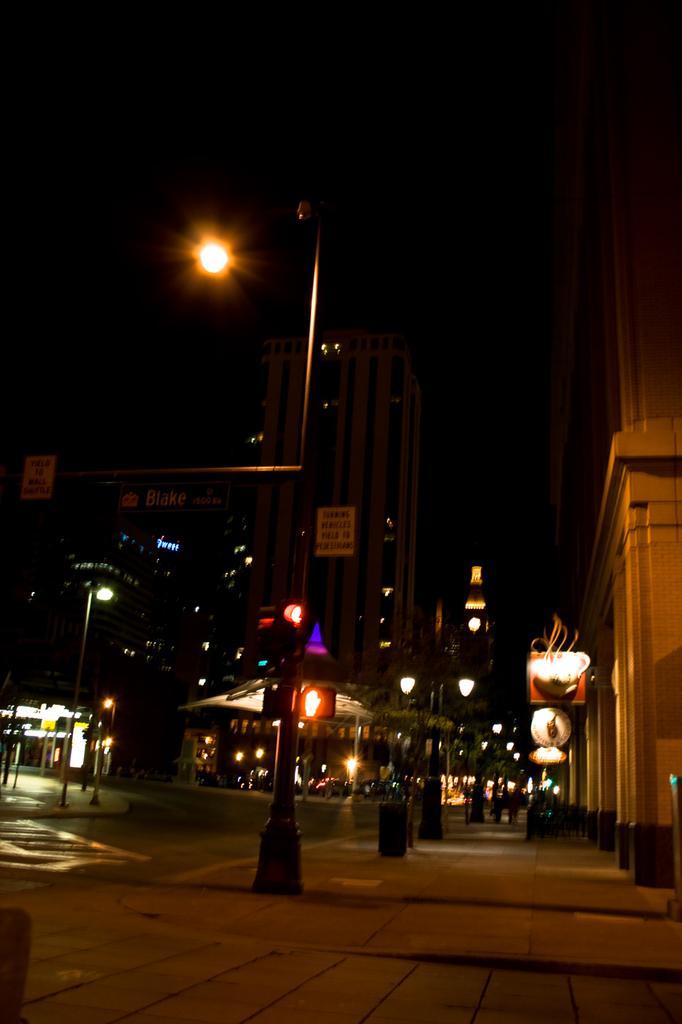Please provide a concise description of this image. In this picture we can see a pole and a light in the front, in the background there are some buildings, poles, lights, hoardings and boards, we can see a dark background. 